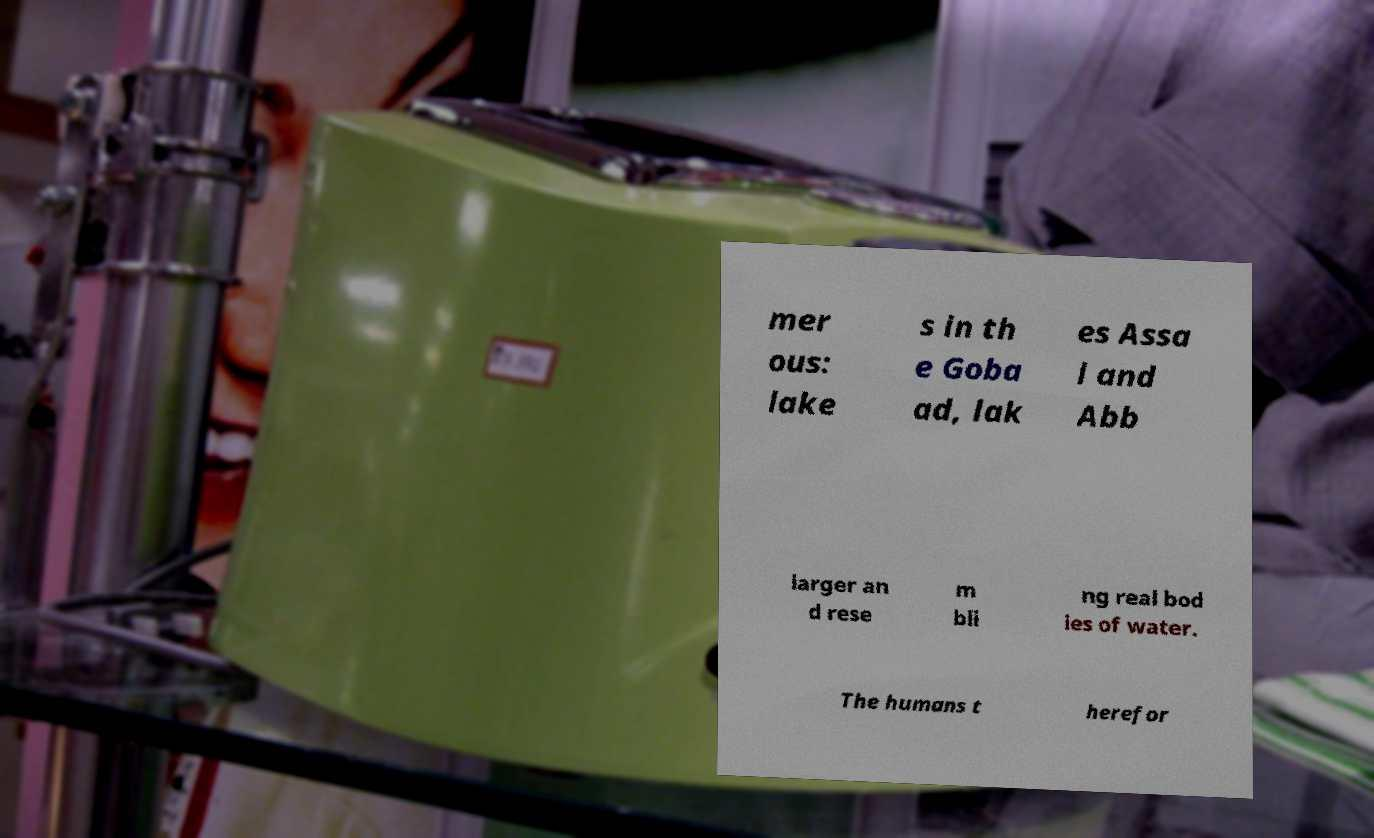For documentation purposes, I need the text within this image transcribed. Could you provide that? mer ous: lake s in th e Goba ad, lak es Assa l and Abb larger an d rese m bli ng real bod ies of water. The humans t herefor 